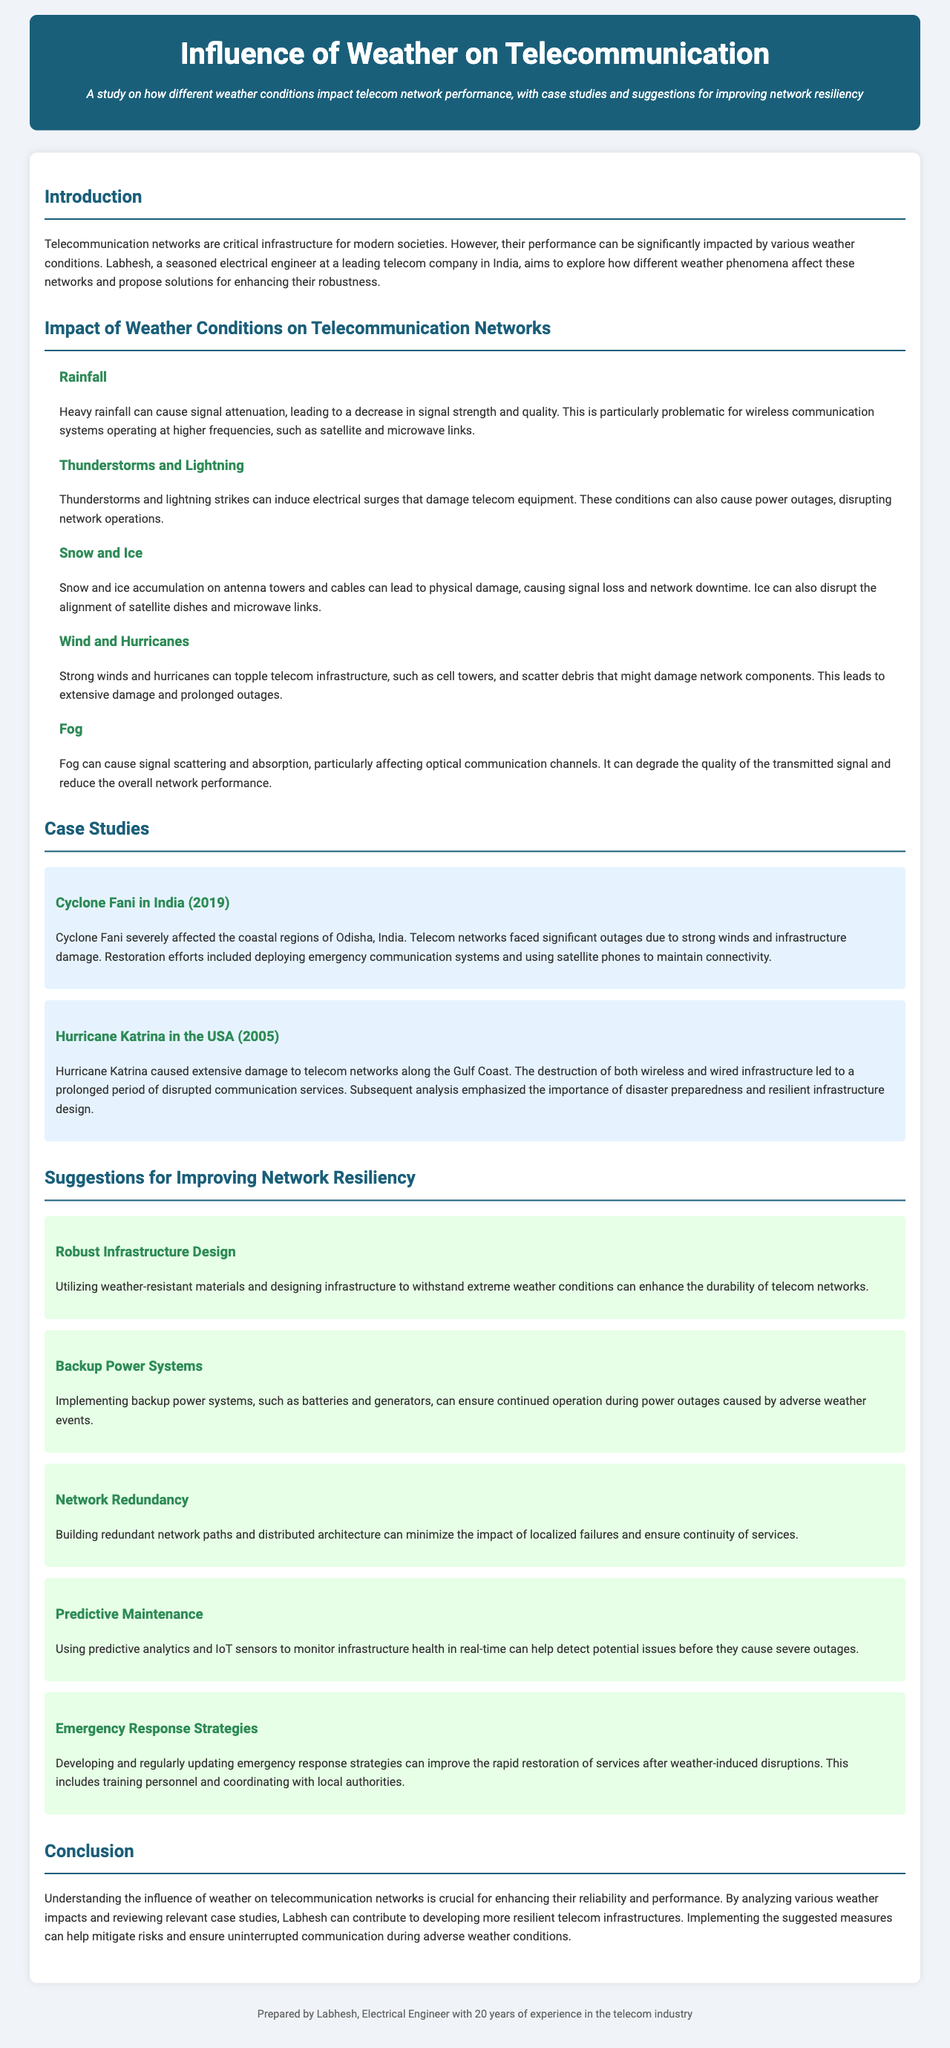What are the two primary weather conditions mentioned that impact telecom networks? The document highlights various weather conditions impacting telecom networks, with a focus on rainfall and thunderstorms.
Answer: Rainfall, thunderstorms What was one of the major causes of outages during Cyclone Fani? The case study on Cyclone Fani mentions that strong winds and infrastructure damage were significant factors leading to telecom outages.
Answer: Strong winds, infrastructure damage How can network resiliency be improved according to the suggestions? The document suggests several measures, with robust infrastructure design being one of them for enhancing network resiliency.
Answer: Robust infrastructure design What year did Hurricane Katrina occur? The case study mentions that Hurricane Katrina occurred in the year 2005.
Answer: 2005 What is one effect of fog on telecommunication networks? The document describes that fog can cause signal scattering and absorption, impacting the quality of transmitted signals.
Answer: Signal scattering, absorption What is suggested for ensuring continued operation during power outages? The suggestion to implement backup power systems, such as batteries and generators, is made for maintaining operation during outages.
Answer: Backup power systems What natural phenomenon is linked to electrical surges damaging telecom equipment? The document indicates that thunderstorms and lightning can induce electrical surges causing damage to telecom equipment.
Answer: Thunderstorms, lightning Which approach can help detect potential issues before severe outages occur? The use of predictive analytics and IoT sensors for monitoring infrastructure health can aid in early detection of issues.
Answer: Predictive maintenance 